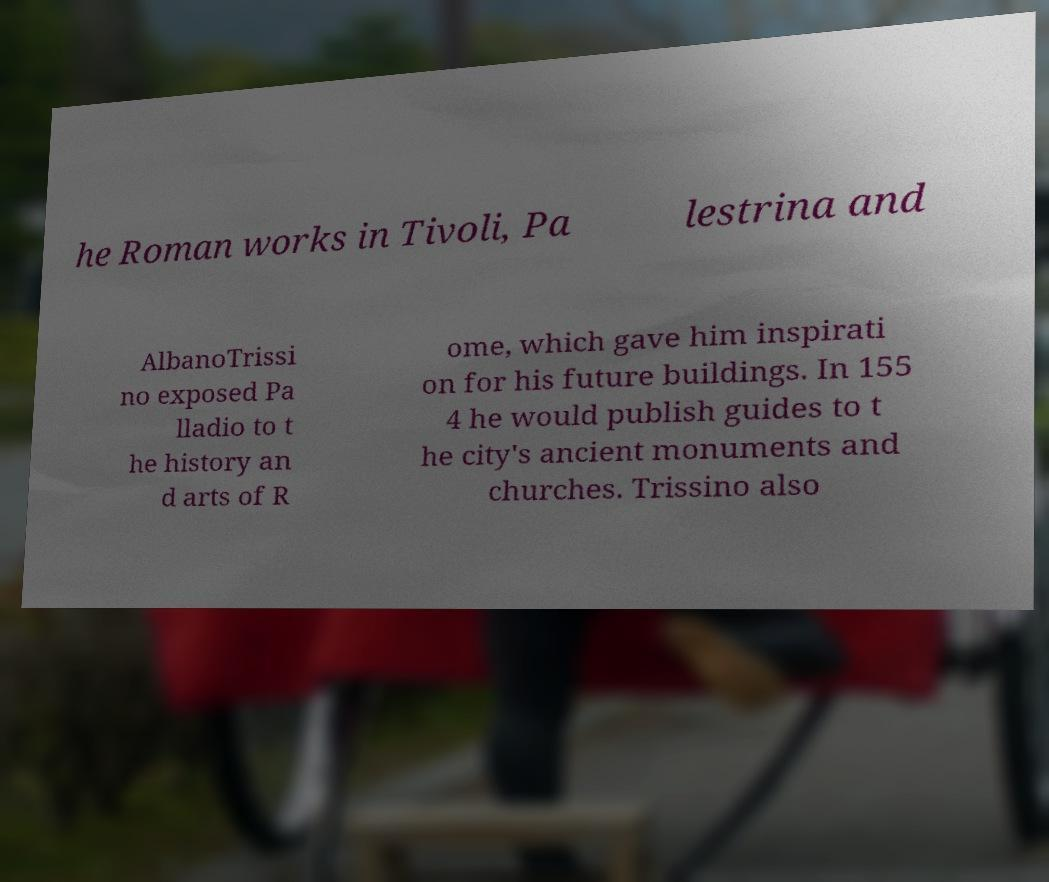I need the written content from this picture converted into text. Can you do that? he Roman works in Tivoli, Pa lestrina and AlbanoTrissi no exposed Pa lladio to t he history an d arts of R ome, which gave him inspirati on for his future buildings. In 155 4 he would publish guides to t he city's ancient monuments and churches. Trissino also 